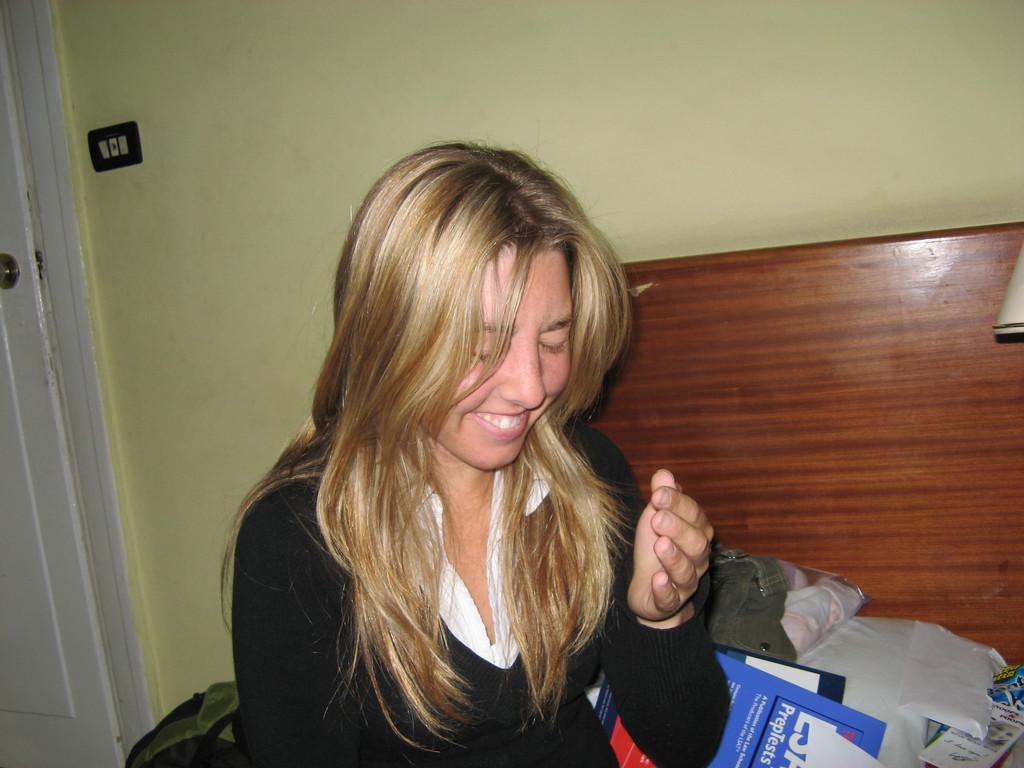How would you summarize this image in a sentence or two? In this image we can see one wooden object looks like a bed near the wall, one woman with smiling face sitting, some objects on the ground, one object near the door, one white door, one switch board attached to the wall and one object near the wooden object on the right side of the image. 